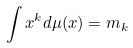Convert formula to latex. <formula><loc_0><loc_0><loc_500><loc_500>\int x ^ { k } d \mu ( x ) = m _ { k }</formula> 